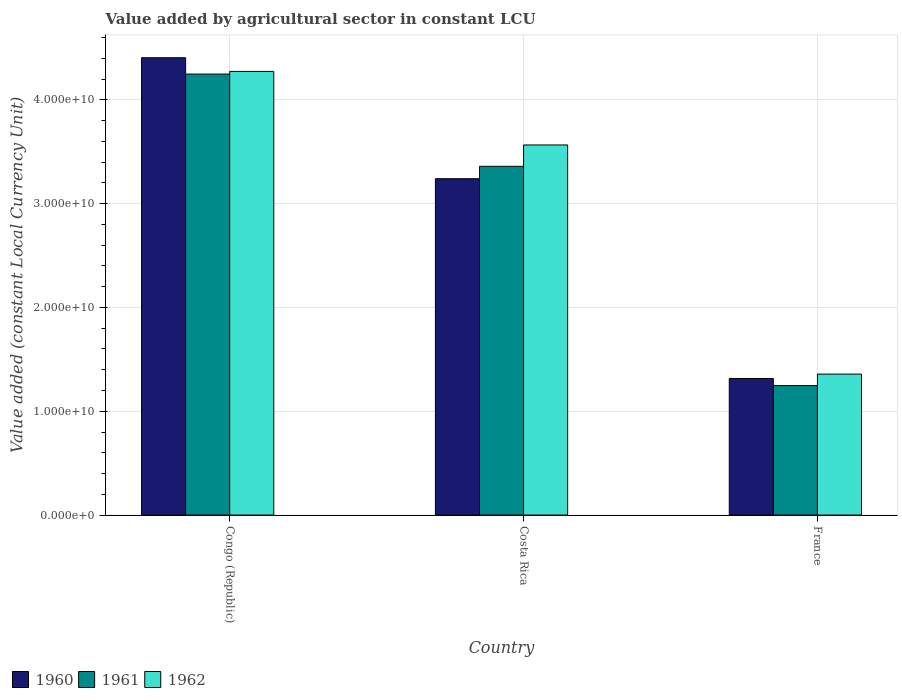How many different coloured bars are there?
Ensure brevity in your answer.  3. How many groups of bars are there?
Give a very brief answer. 3. Are the number of bars per tick equal to the number of legend labels?
Your response must be concise. Yes. How many bars are there on the 3rd tick from the right?
Offer a terse response. 3. What is the label of the 1st group of bars from the left?
Offer a very short reply. Congo (Republic). In how many cases, is the number of bars for a given country not equal to the number of legend labels?
Your answer should be very brief. 0. What is the value added by agricultural sector in 1962 in France?
Your answer should be compact. 1.36e+1. Across all countries, what is the maximum value added by agricultural sector in 1960?
Provide a succinct answer. 4.41e+1. Across all countries, what is the minimum value added by agricultural sector in 1962?
Provide a short and direct response. 1.36e+1. In which country was the value added by agricultural sector in 1961 maximum?
Provide a short and direct response. Congo (Republic). What is the total value added by agricultural sector in 1962 in the graph?
Provide a short and direct response. 9.20e+1. What is the difference between the value added by agricultural sector in 1960 in Costa Rica and that in France?
Your answer should be very brief. 1.92e+1. What is the difference between the value added by agricultural sector in 1960 in Congo (Republic) and the value added by agricultural sector in 1961 in Costa Rica?
Offer a very short reply. 1.05e+1. What is the average value added by agricultural sector in 1962 per country?
Offer a very short reply. 3.07e+1. What is the difference between the value added by agricultural sector of/in 1961 and value added by agricultural sector of/in 1960 in Congo (Republic)?
Ensure brevity in your answer.  -1.57e+09. In how many countries, is the value added by agricultural sector in 1960 greater than 30000000000 LCU?
Make the answer very short. 2. What is the ratio of the value added by agricultural sector in 1961 in Costa Rica to that in France?
Keep it short and to the point. 2.69. Is the value added by agricultural sector in 1962 in Congo (Republic) less than that in Costa Rica?
Provide a succinct answer. No. What is the difference between the highest and the second highest value added by agricultural sector in 1960?
Ensure brevity in your answer.  -1.92e+1. What is the difference between the highest and the lowest value added by agricultural sector in 1960?
Give a very brief answer. 3.09e+1. How many bars are there?
Your response must be concise. 9. What is the difference between two consecutive major ticks on the Y-axis?
Offer a terse response. 1.00e+1. Are the values on the major ticks of Y-axis written in scientific E-notation?
Offer a very short reply. Yes. Does the graph contain grids?
Your answer should be compact. Yes. How are the legend labels stacked?
Keep it short and to the point. Horizontal. What is the title of the graph?
Give a very brief answer. Value added by agricultural sector in constant LCU. What is the label or title of the X-axis?
Your answer should be compact. Country. What is the label or title of the Y-axis?
Ensure brevity in your answer.  Value added (constant Local Currency Unit). What is the Value added (constant Local Currency Unit) in 1960 in Congo (Republic)?
Your answer should be very brief. 4.41e+1. What is the Value added (constant Local Currency Unit) of 1961 in Congo (Republic)?
Your answer should be very brief. 4.25e+1. What is the Value added (constant Local Currency Unit) of 1962 in Congo (Republic)?
Ensure brevity in your answer.  4.27e+1. What is the Value added (constant Local Currency Unit) of 1960 in Costa Rica?
Keep it short and to the point. 3.24e+1. What is the Value added (constant Local Currency Unit) in 1961 in Costa Rica?
Your answer should be very brief. 3.36e+1. What is the Value added (constant Local Currency Unit) of 1962 in Costa Rica?
Your response must be concise. 3.57e+1. What is the Value added (constant Local Currency Unit) in 1960 in France?
Give a very brief answer. 1.32e+1. What is the Value added (constant Local Currency Unit) of 1961 in France?
Keep it short and to the point. 1.25e+1. What is the Value added (constant Local Currency Unit) of 1962 in France?
Provide a short and direct response. 1.36e+1. Across all countries, what is the maximum Value added (constant Local Currency Unit) in 1960?
Offer a terse response. 4.41e+1. Across all countries, what is the maximum Value added (constant Local Currency Unit) in 1961?
Your response must be concise. 4.25e+1. Across all countries, what is the maximum Value added (constant Local Currency Unit) in 1962?
Your response must be concise. 4.27e+1. Across all countries, what is the minimum Value added (constant Local Currency Unit) in 1960?
Your response must be concise. 1.32e+1. Across all countries, what is the minimum Value added (constant Local Currency Unit) in 1961?
Offer a very short reply. 1.25e+1. Across all countries, what is the minimum Value added (constant Local Currency Unit) of 1962?
Your answer should be very brief. 1.36e+1. What is the total Value added (constant Local Currency Unit) in 1960 in the graph?
Your answer should be compact. 8.96e+1. What is the total Value added (constant Local Currency Unit) in 1961 in the graph?
Provide a succinct answer. 8.86e+1. What is the total Value added (constant Local Currency Unit) of 1962 in the graph?
Give a very brief answer. 9.20e+1. What is the difference between the Value added (constant Local Currency Unit) in 1960 in Congo (Republic) and that in Costa Rica?
Ensure brevity in your answer.  1.17e+1. What is the difference between the Value added (constant Local Currency Unit) in 1961 in Congo (Republic) and that in Costa Rica?
Your answer should be very brief. 8.89e+09. What is the difference between the Value added (constant Local Currency Unit) of 1962 in Congo (Republic) and that in Costa Rica?
Provide a succinct answer. 7.08e+09. What is the difference between the Value added (constant Local Currency Unit) in 1960 in Congo (Republic) and that in France?
Provide a succinct answer. 3.09e+1. What is the difference between the Value added (constant Local Currency Unit) in 1961 in Congo (Republic) and that in France?
Make the answer very short. 3.00e+1. What is the difference between the Value added (constant Local Currency Unit) in 1962 in Congo (Republic) and that in France?
Give a very brief answer. 2.92e+1. What is the difference between the Value added (constant Local Currency Unit) of 1960 in Costa Rica and that in France?
Your answer should be very brief. 1.92e+1. What is the difference between the Value added (constant Local Currency Unit) in 1961 in Costa Rica and that in France?
Your answer should be compact. 2.11e+1. What is the difference between the Value added (constant Local Currency Unit) in 1962 in Costa Rica and that in France?
Your answer should be compact. 2.21e+1. What is the difference between the Value added (constant Local Currency Unit) in 1960 in Congo (Republic) and the Value added (constant Local Currency Unit) in 1961 in Costa Rica?
Your answer should be very brief. 1.05e+1. What is the difference between the Value added (constant Local Currency Unit) of 1960 in Congo (Republic) and the Value added (constant Local Currency Unit) of 1962 in Costa Rica?
Provide a succinct answer. 8.40e+09. What is the difference between the Value added (constant Local Currency Unit) in 1961 in Congo (Republic) and the Value added (constant Local Currency Unit) in 1962 in Costa Rica?
Provide a succinct answer. 6.83e+09. What is the difference between the Value added (constant Local Currency Unit) in 1960 in Congo (Republic) and the Value added (constant Local Currency Unit) in 1961 in France?
Offer a very short reply. 3.16e+1. What is the difference between the Value added (constant Local Currency Unit) of 1960 in Congo (Republic) and the Value added (constant Local Currency Unit) of 1962 in France?
Your answer should be very brief. 3.05e+1. What is the difference between the Value added (constant Local Currency Unit) in 1961 in Congo (Republic) and the Value added (constant Local Currency Unit) in 1962 in France?
Your answer should be compact. 2.89e+1. What is the difference between the Value added (constant Local Currency Unit) in 1960 in Costa Rica and the Value added (constant Local Currency Unit) in 1961 in France?
Provide a succinct answer. 1.99e+1. What is the difference between the Value added (constant Local Currency Unit) in 1960 in Costa Rica and the Value added (constant Local Currency Unit) in 1962 in France?
Provide a succinct answer. 1.88e+1. What is the difference between the Value added (constant Local Currency Unit) in 1961 in Costa Rica and the Value added (constant Local Currency Unit) in 1962 in France?
Provide a short and direct response. 2.00e+1. What is the average Value added (constant Local Currency Unit) of 1960 per country?
Ensure brevity in your answer.  2.99e+1. What is the average Value added (constant Local Currency Unit) in 1961 per country?
Ensure brevity in your answer.  2.95e+1. What is the average Value added (constant Local Currency Unit) in 1962 per country?
Your answer should be very brief. 3.07e+1. What is the difference between the Value added (constant Local Currency Unit) of 1960 and Value added (constant Local Currency Unit) of 1961 in Congo (Republic)?
Give a very brief answer. 1.57e+09. What is the difference between the Value added (constant Local Currency Unit) in 1960 and Value added (constant Local Currency Unit) in 1962 in Congo (Republic)?
Your answer should be very brief. 1.32e+09. What is the difference between the Value added (constant Local Currency Unit) of 1961 and Value added (constant Local Currency Unit) of 1962 in Congo (Republic)?
Your response must be concise. -2.56e+08. What is the difference between the Value added (constant Local Currency Unit) of 1960 and Value added (constant Local Currency Unit) of 1961 in Costa Rica?
Your answer should be compact. -1.19e+09. What is the difference between the Value added (constant Local Currency Unit) of 1960 and Value added (constant Local Currency Unit) of 1962 in Costa Rica?
Ensure brevity in your answer.  -3.25e+09. What is the difference between the Value added (constant Local Currency Unit) in 1961 and Value added (constant Local Currency Unit) in 1962 in Costa Rica?
Make the answer very short. -2.06e+09. What is the difference between the Value added (constant Local Currency Unit) in 1960 and Value added (constant Local Currency Unit) in 1961 in France?
Keep it short and to the point. 6.84e+08. What is the difference between the Value added (constant Local Currency Unit) in 1960 and Value added (constant Local Currency Unit) in 1962 in France?
Your response must be concise. -4.23e+08. What is the difference between the Value added (constant Local Currency Unit) of 1961 and Value added (constant Local Currency Unit) of 1962 in France?
Give a very brief answer. -1.11e+09. What is the ratio of the Value added (constant Local Currency Unit) of 1960 in Congo (Republic) to that in Costa Rica?
Ensure brevity in your answer.  1.36. What is the ratio of the Value added (constant Local Currency Unit) of 1961 in Congo (Republic) to that in Costa Rica?
Make the answer very short. 1.26. What is the ratio of the Value added (constant Local Currency Unit) of 1962 in Congo (Republic) to that in Costa Rica?
Provide a succinct answer. 1.2. What is the ratio of the Value added (constant Local Currency Unit) of 1960 in Congo (Republic) to that in France?
Keep it short and to the point. 3.35. What is the ratio of the Value added (constant Local Currency Unit) in 1961 in Congo (Republic) to that in France?
Make the answer very short. 3.41. What is the ratio of the Value added (constant Local Currency Unit) of 1962 in Congo (Republic) to that in France?
Offer a terse response. 3.15. What is the ratio of the Value added (constant Local Currency Unit) of 1960 in Costa Rica to that in France?
Your answer should be compact. 2.46. What is the ratio of the Value added (constant Local Currency Unit) in 1961 in Costa Rica to that in France?
Provide a short and direct response. 2.69. What is the ratio of the Value added (constant Local Currency Unit) in 1962 in Costa Rica to that in France?
Provide a short and direct response. 2.63. What is the difference between the highest and the second highest Value added (constant Local Currency Unit) of 1960?
Ensure brevity in your answer.  1.17e+1. What is the difference between the highest and the second highest Value added (constant Local Currency Unit) of 1961?
Your response must be concise. 8.89e+09. What is the difference between the highest and the second highest Value added (constant Local Currency Unit) of 1962?
Offer a very short reply. 7.08e+09. What is the difference between the highest and the lowest Value added (constant Local Currency Unit) of 1960?
Provide a short and direct response. 3.09e+1. What is the difference between the highest and the lowest Value added (constant Local Currency Unit) in 1961?
Your answer should be very brief. 3.00e+1. What is the difference between the highest and the lowest Value added (constant Local Currency Unit) in 1962?
Your answer should be very brief. 2.92e+1. 